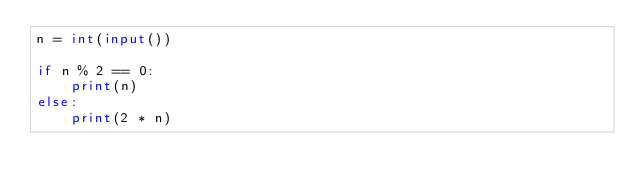Convert code to text. <code><loc_0><loc_0><loc_500><loc_500><_Python_>n = int(input())

if n % 2 == 0:
    print(n)
else:
    print(2 * n)
</code> 